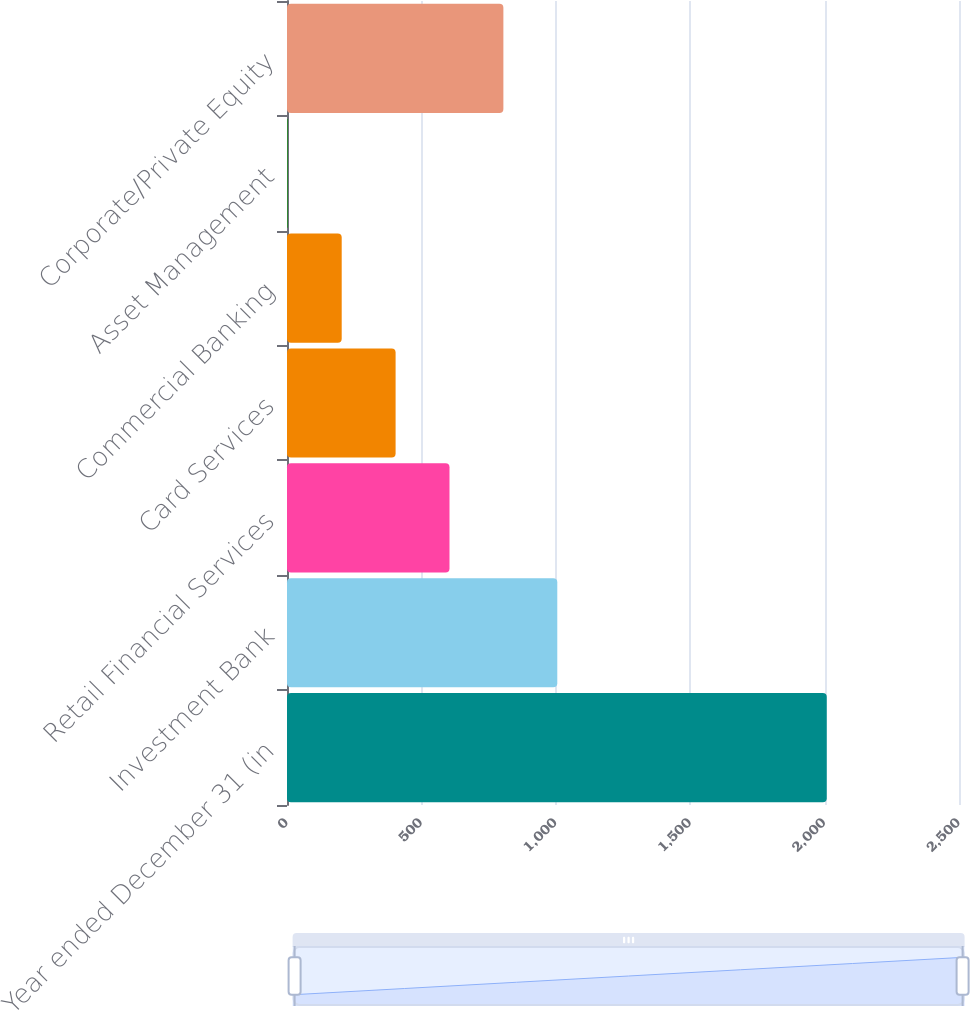Convert chart to OTSL. <chart><loc_0><loc_0><loc_500><loc_500><bar_chart><fcel>Year ended December 31 (in<fcel>Investment Bank<fcel>Retail Financial Services<fcel>Card Services<fcel>Commercial Banking<fcel>Asset Management<fcel>Corporate/Private Equity<nl><fcel>2008<fcel>1005.5<fcel>604.5<fcel>404<fcel>203.5<fcel>3<fcel>805<nl></chart> 